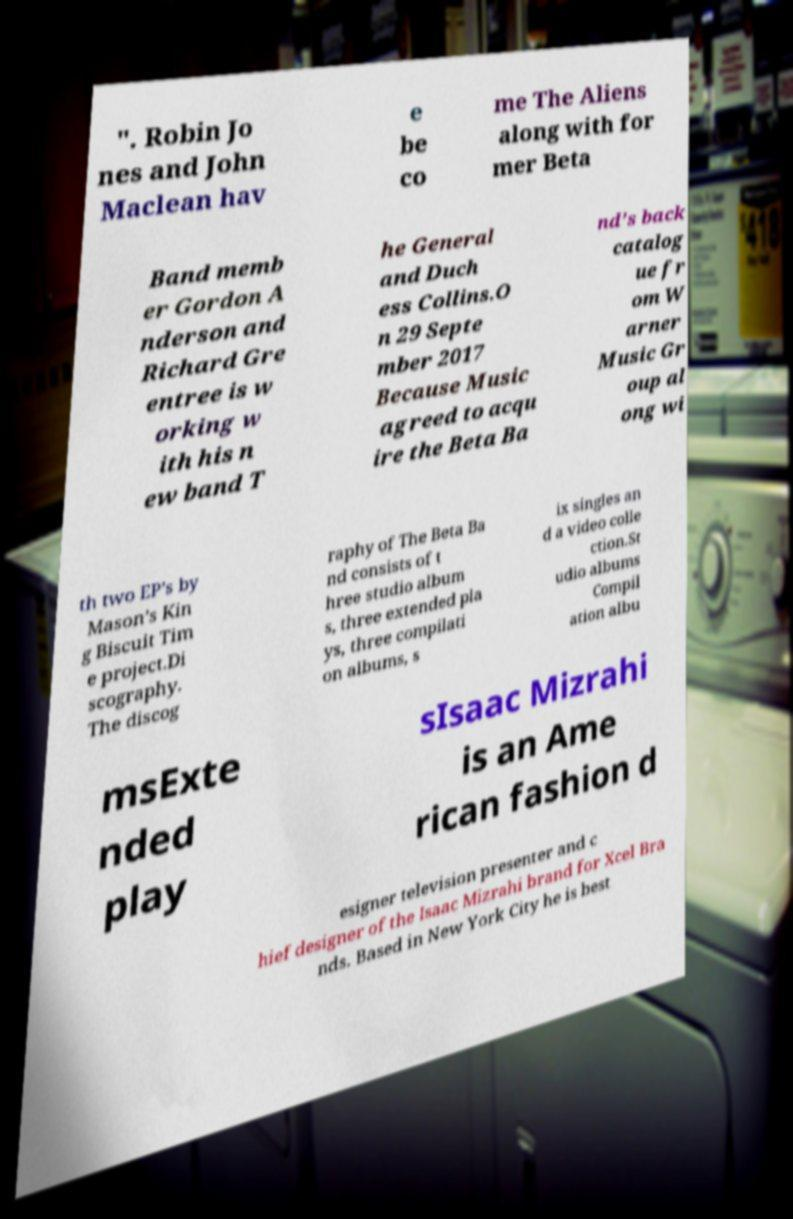I need the written content from this picture converted into text. Can you do that? ". Robin Jo nes and John Maclean hav e be co me The Aliens along with for mer Beta Band memb er Gordon A nderson and Richard Gre entree is w orking w ith his n ew band T he General and Duch ess Collins.O n 29 Septe mber 2017 Because Music agreed to acqu ire the Beta Ba nd’s back catalog ue fr om W arner Music Gr oup al ong wi th two EP’s by Mason’s Kin g Biscuit Tim e project.Di scography. The discog raphy of The Beta Ba nd consists of t hree studio album s, three extended pla ys, three compilati on albums, s ix singles an d a video colle ction.St udio albums Compil ation albu msExte nded play sIsaac Mizrahi is an Ame rican fashion d esigner television presenter and c hief designer of the Isaac Mizrahi brand for Xcel Bra nds. Based in New York City he is best 